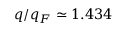Convert formula to latex. <formula><loc_0><loc_0><loc_500><loc_500>q / q _ { F } \simeq 1 . 4 3 4</formula> 